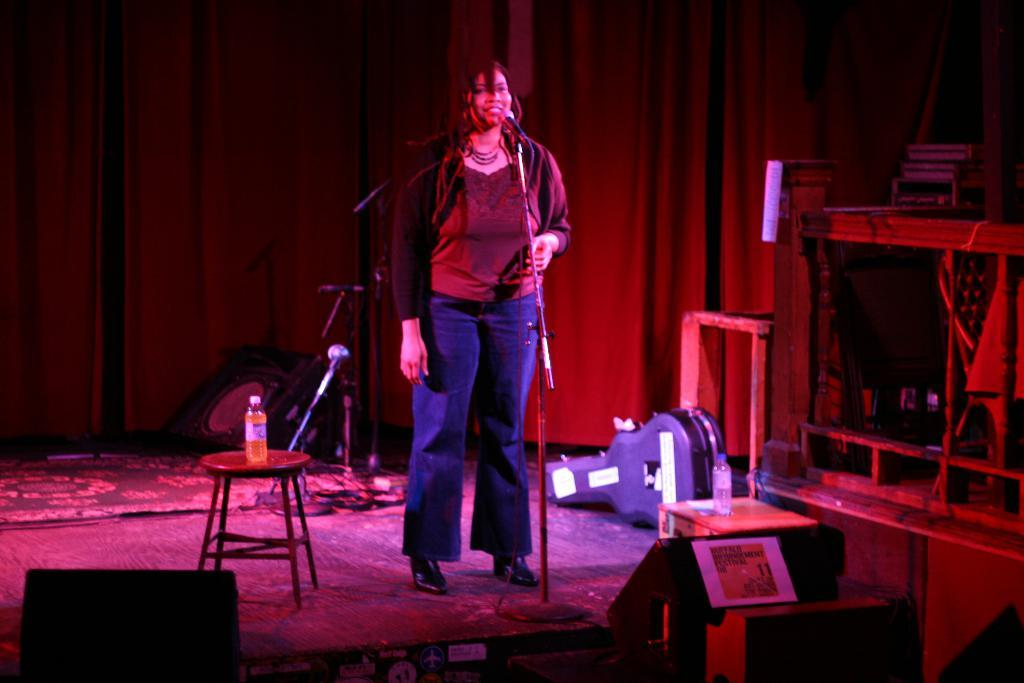What is the person in the image doing? The person is standing in front of a microphone. What can be seen on the table in the background? There is there anything else on the table? What can be seen in the background of the image? There are other objects visible in the background, but their specific details are not mentioned in the facts. What type of lighting is present in the image? Colorful lights are present in the image. What type of lunch is being served in the image? There is no mention of lunch or any food items in the image. 